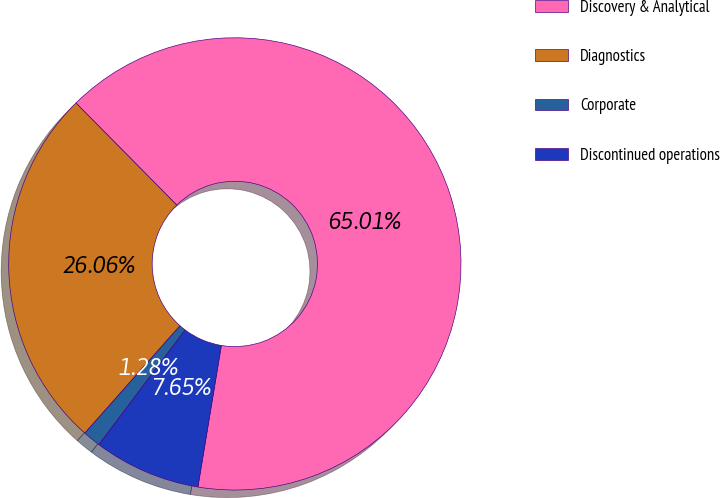<chart> <loc_0><loc_0><loc_500><loc_500><pie_chart><fcel>Discovery & Analytical<fcel>Diagnostics<fcel>Corporate<fcel>Discontinued operations<nl><fcel>65.01%<fcel>26.06%<fcel>1.28%<fcel>7.65%<nl></chart> 